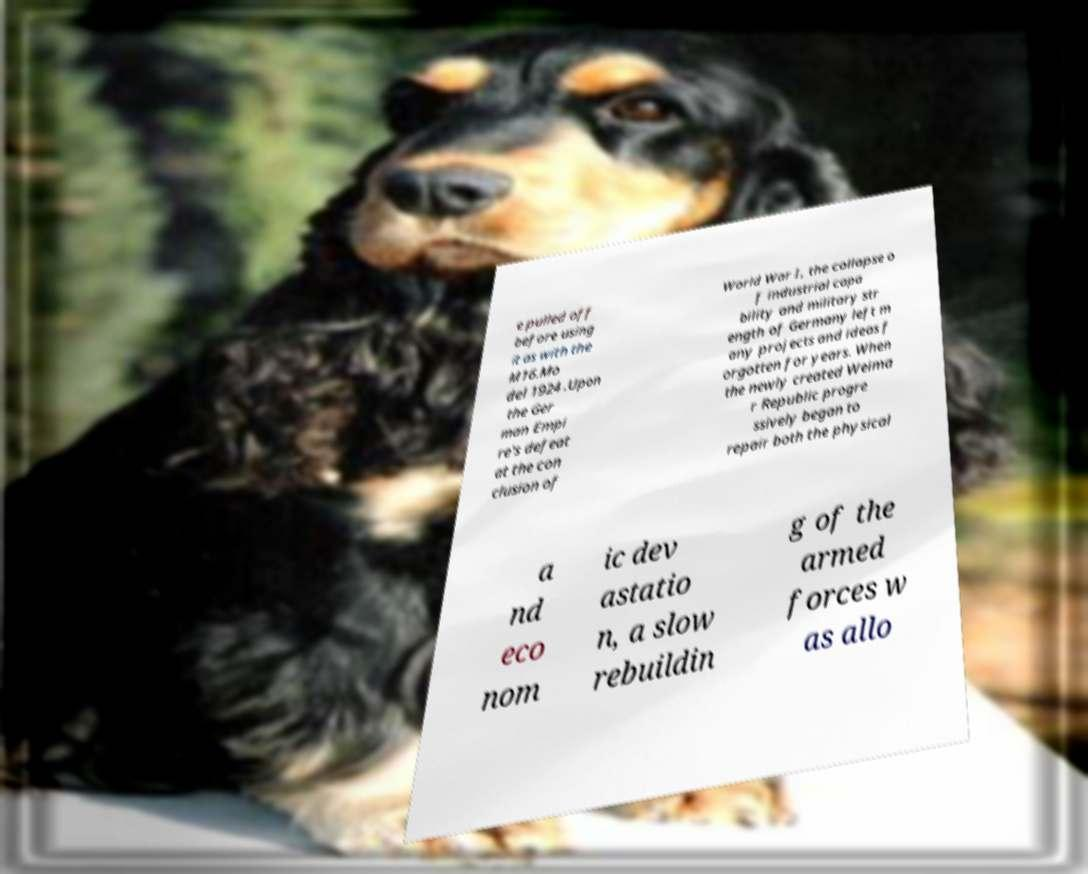Can you read and provide the text displayed in the image?This photo seems to have some interesting text. Can you extract and type it out for me? e pulled off before using it as with the M16.Mo del 1924 .Upon the Ger man Empi re's defeat at the con clusion of World War I, the collapse o f industrial capa bility and military str ength of Germany left m any projects and ideas f orgotten for years. When the newly created Weima r Republic progre ssively began to repair both the physical a nd eco nom ic dev astatio n, a slow rebuildin g of the armed forces w as allo 